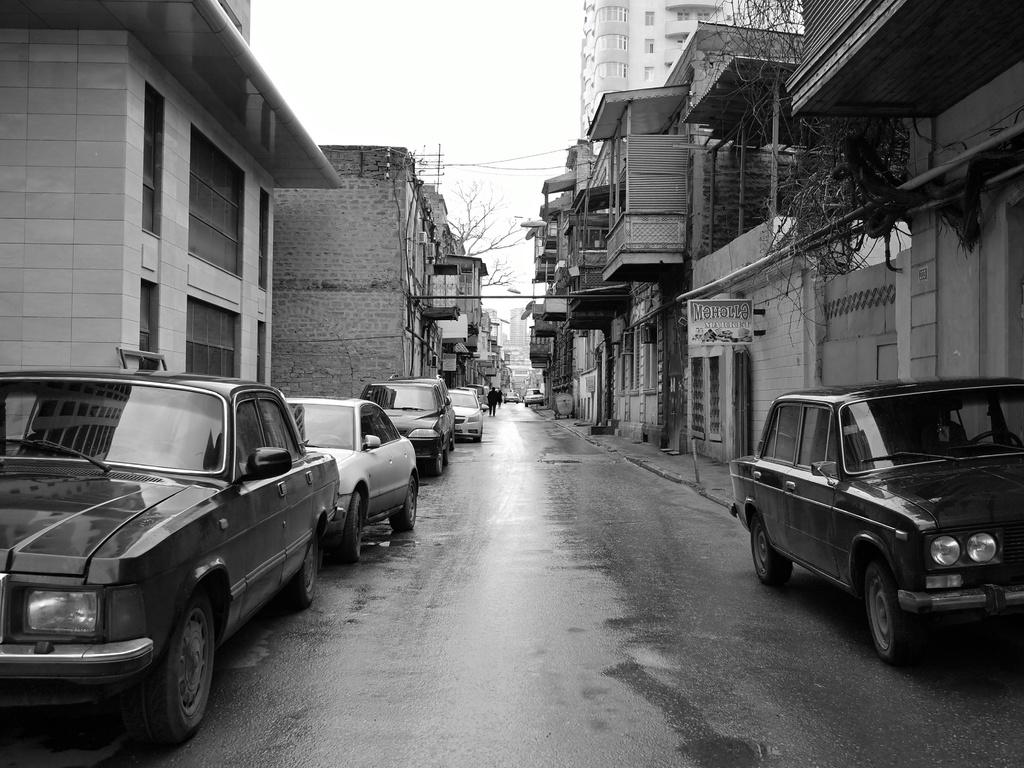What can be seen on the road in the image? There are cars parked on the road. Are there any people visible on the road? Yes, there is a person walking on the road. What type of vegetation is present on either side of the road? There are trees on either side of the road. What type of structures can be seen on either side of the road? There are buildings on either side of the road. What type of corn is growing on the buildings in the image? There is no corn present in the image; it features cars, a person walking, trees, and buildings. What is the limit of the person's walking speed in the image? The image does not provide information about the person's walking speed, so it cannot be determined. 